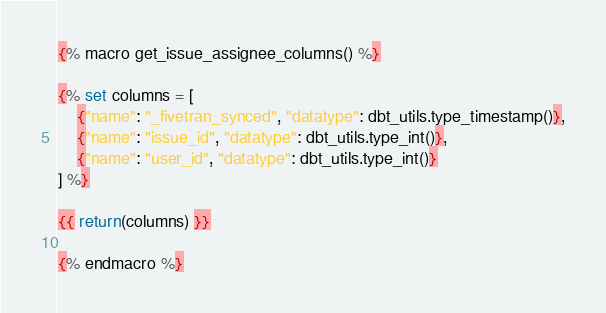<code> <loc_0><loc_0><loc_500><loc_500><_SQL_>{% macro get_issue_assignee_columns() %}

{% set columns = [
    {"name": "_fivetran_synced", "datatype": dbt_utils.type_timestamp()},
    {"name": "issue_id", "datatype": dbt_utils.type_int()},
    {"name": "user_id", "datatype": dbt_utils.type_int()}
] %}

{{ return(columns) }}

{% endmacro %}
</code> 